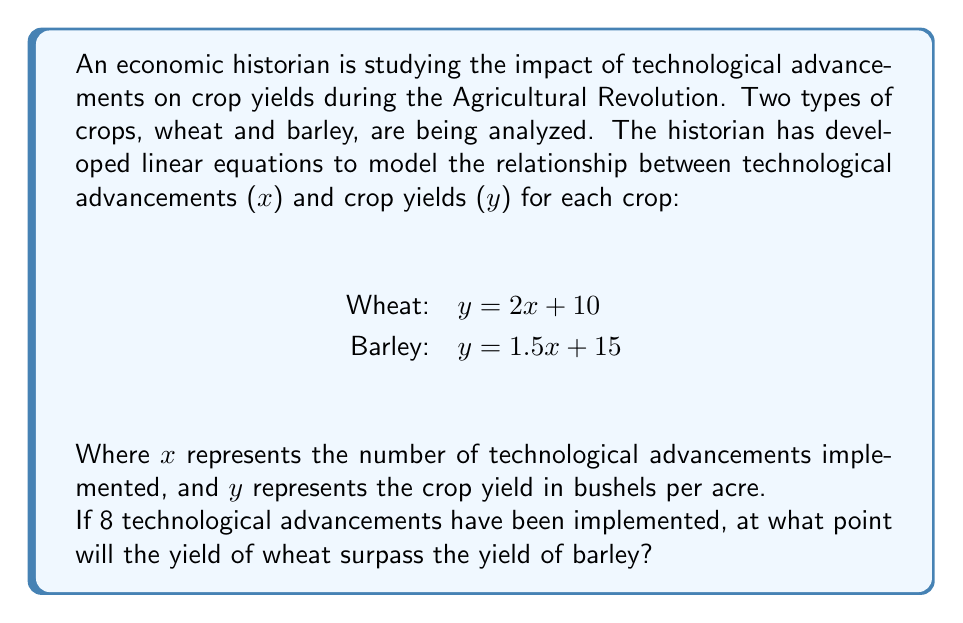Give your solution to this math problem. To solve this problem, we need to follow these steps:

1. Set up the equations for wheat and barley yields:
   Wheat: $y_w = 2x + 10$
   Barley: $y_b = 1.5x + 15$

2. We want to find the point where wheat yield equals barley yield, so set the equations equal to each other:
   $2x + 10 = 1.5x + 15$

3. Solve for x:
   $2x + 10 = 1.5x + 15$
   $2x - 1.5x = 15 - 10$
   $0.5x = 5$
   $x = 10$

4. This means that at 10 technological advancements, the yields will be equal. To determine when wheat surpasses barley, we need to check the next whole number of advancements, which is 11.

5. Calculate the yields at 11 advancements:
   Wheat: $y_w = 2(11) + 10 = 32$ bushels per acre
   Barley: $y_b = 1.5(11) + 15 = 31.5$ bushels per acre

6. Since we started at 8 advancements, we need to count how many more advancements are needed to reach 11:
   $11 - 8 = 3$

Therefore, wheat yield will surpass barley yield after 3 more technological advancements from the initial 8.
Answer: 3 advancements 